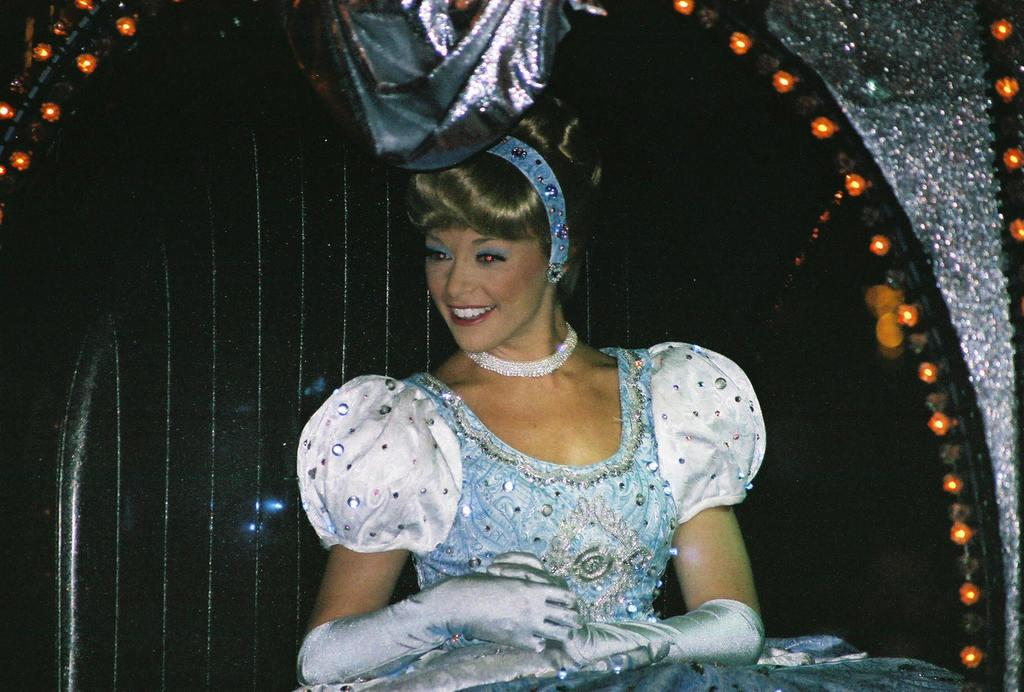Who is in the picture? There is a woman in the picture. What is the woman wearing? The woman is wearing a dress, gloves, and a locket. What is the woman doing in the picture? The woman is sitting on a chair. What can be seen on the chair? There are lights on the corners of the chair. What type of poison is the woman holding in the picture? There is no poison present in the image; the woman is wearing a locket and sitting on a chair. Can you tell me how many giraffes are visible in the picture? There are no giraffes present in the image. 